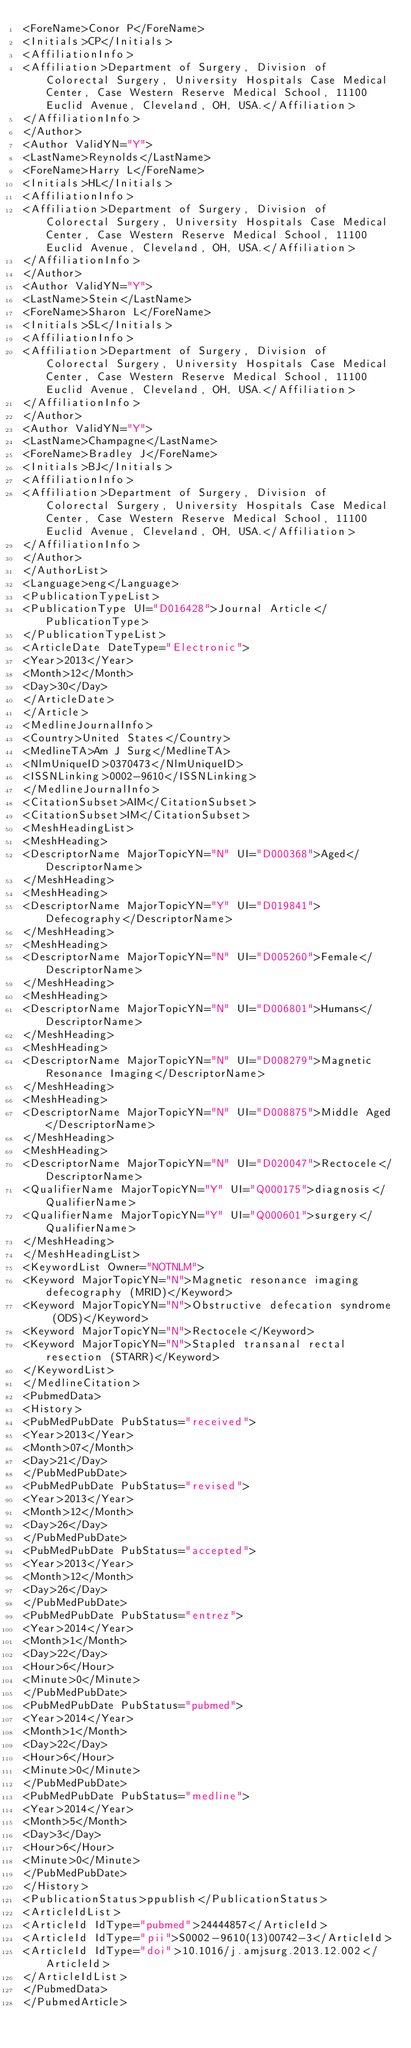Convert code to text. <code><loc_0><loc_0><loc_500><loc_500><_XML_><ForeName>Conor P</ForeName>
<Initials>CP</Initials>
<AffiliationInfo>
<Affiliation>Department of Surgery, Division of Colorectal Surgery, University Hospitals Case Medical Center, Case Western Reserve Medical School, 11100 Euclid Avenue, Cleveland, OH, USA.</Affiliation>
</AffiliationInfo>
</Author>
<Author ValidYN="Y">
<LastName>Reynolds</LastName>
<ForeName>Harry L</ForeName>
<Initials>HL</Initials>
<AffiliationInfo>
<Affiliation>Department of Surgery, Division of Colorectal Surgery, University Hospitals Case Medical Center, Case Western Reserve Medical School, 11100 Euclid Avenue, Cleveland, OH, USA.</Affiliation>
</AffiliationInfo>
</Author>
<Author ValidYN="Y">
<LastName>Stein</LastName>
<ForeName>Sharon L</ForeName>
<Initials>SL</Initials>
<AffiliationInfo>
<Affiliation>Department of Surgery, Division of Colorectal Surgery, University Hospitals Case Medical Center, Case Western Reserve Medical School, 11100 Euclid Avenue, Cleveland, OH, USA.</Affiliation>
</AffiliationInfo>
</Author>
<Author ValidYN="Y">
<LastName>Champagne</LastName>
<ForeName>Bradley J</ForeName>
<Initials>BJ</Initials>
<AffiliationInfo>
<Affiliation>Department of Surgery, Division of Colorectal Surgery, University Hospitals Case Medical Center, Case Western Reserve Medical School, 11100 Euclid Avenue, Cleveland, OH, USA.</Affiliation>
</AffiliationInfo>
</Author>
</AuthorList>
<Language>eng</Language>
<PublicationTypeList>
<PublicationType UI="D016428">Journal Article</PublicationType>
</PublicationTypeList>
<ArticleDate DateType="Electronic">
<Year>2013</Year>
<Month>12</Month>
<Day>30</Day>
</ArticleDate>
</Article>
<MedlineJournalInfo>
<Country>United States</Country>
<MedlineTA>Am J Surg</MedlineTA>
<NlmUniqueID>0370473</NlmUniqueID>
<ISSNLinking>0002-9610</ISSNLinking>
</MedlineJournalInfo>
<CitationSubset>AIM</CitationSubset>
<CitationSubset>IM</CitationSubset>
<MeshHeadingList>
<MeshHeading>
<DescriptorName MajorTopicYN="N" UI="D000368">Aged</DescriptorName>
</MeshHeading>
<MeshHeading>
<DescriptorName MajorTopicYN="Y" UI="D019841">Defecography</DescriptorName>
</MeshHeading>
<MeshHeading>
<DescriptorName MajorTopicYN="N" UI="D005260">Female</DescriptorName>
</MeshHeading>
<MeshHeading>
<DescriptorName MajorTopicYN="N" UI="D006801">Humans</DescriptorName>
</MeshHeading>
<MeshHeading>
<DescriptorName MajorTopicYN="N" UI="D008279">Magnetic Resonance Imaging</DescriptorName>
</MeshHeading>
<MeshHeading>
<DescriptorName MajorTopicYN="N" UI="D008875">Middle Aged</DescriptorName>
</MeshHeading>
<MeshHeading>
<DescriptorName MajorTopicYN="N" UI="D020047">Rectocele</DescriptorName>
<QualifierName MajorTopicYN="Y" UI="Q000175">diagnosis</QualifierName>
<QualifierName MajorTopicYN="Y" UI="Q000601">surgery</QualifierName>
</MeshHeading>
</MeshHeadingList>
<KeywordList Owner="NOTNLM">
<Keyword MajorTopicYN="N">Magnetic resonance imaging defecography (MRID)</Keyword>
<Keyword MajorTopicYN="N">Obstructive defecation syndrome (ODS)</Keyword>
<Keyword MajorTopicYN="N">Rectocele</Keyword>
<Keyword MajorTopicYN="N">Stapled transanal rectal resection (STARR)</Keyword>
</KeywordList>
</MedlineCitation>
<PubmedData>
<History>
<PubMedPubDate PubStatus="received">
<Year>2013</Year>
<Month>07</Month>
<Day>21</Day>
</PubMedPubDate>
<PubMedPubDate PubStatus="revised">
<Year>2013</Year>
<Month>12</Month>
<Day>26</Day>
</PubMedPubDate>
<PubMedPubDate PubStatus="accepted">
<Year>2013</Year>
<Month>12</Month>
<Day>26</Day>
</PubMedPubDate>
<PubMedPubDate PubStatus="entrez">
<Year>2014</Year>
<Month>1</Month>
<Day>22</Day>
<Hour>6</Hour>
<Minute>0</Minute>
</PubMedPubDate>
<PubMedPubDate PubStatus="pubmed">
<Year>2014</Year>
<Month>1</Month>
<Day>22</Day>
<Hour>6</Hour>
<Minute>0</Minute>
</PubMedPubDate>
<PubMedPubDate PubStatus="medline">
<Year>2014</Year>
<Month>5</Month>
<Day>3</Day>
<Hour>6</Hour>
<Minute>0</Minute>
</PubMedPubDate>
</History>
<PublicationStatus>ppublish</PublicationStatus>
<ArticleIdList>
<ArticleId IdType="pubmed">24444857</ArticleId>
<ArticleId IdType="pii">S0002-9610(13)00742-3</ArticleId>
<ArticleId IdType="doi">10.1016/j.amjsurg.2013.12.002</ArticleId>
</ArticleIdList>
</PubmedData>
</PubmedArticle></code> 